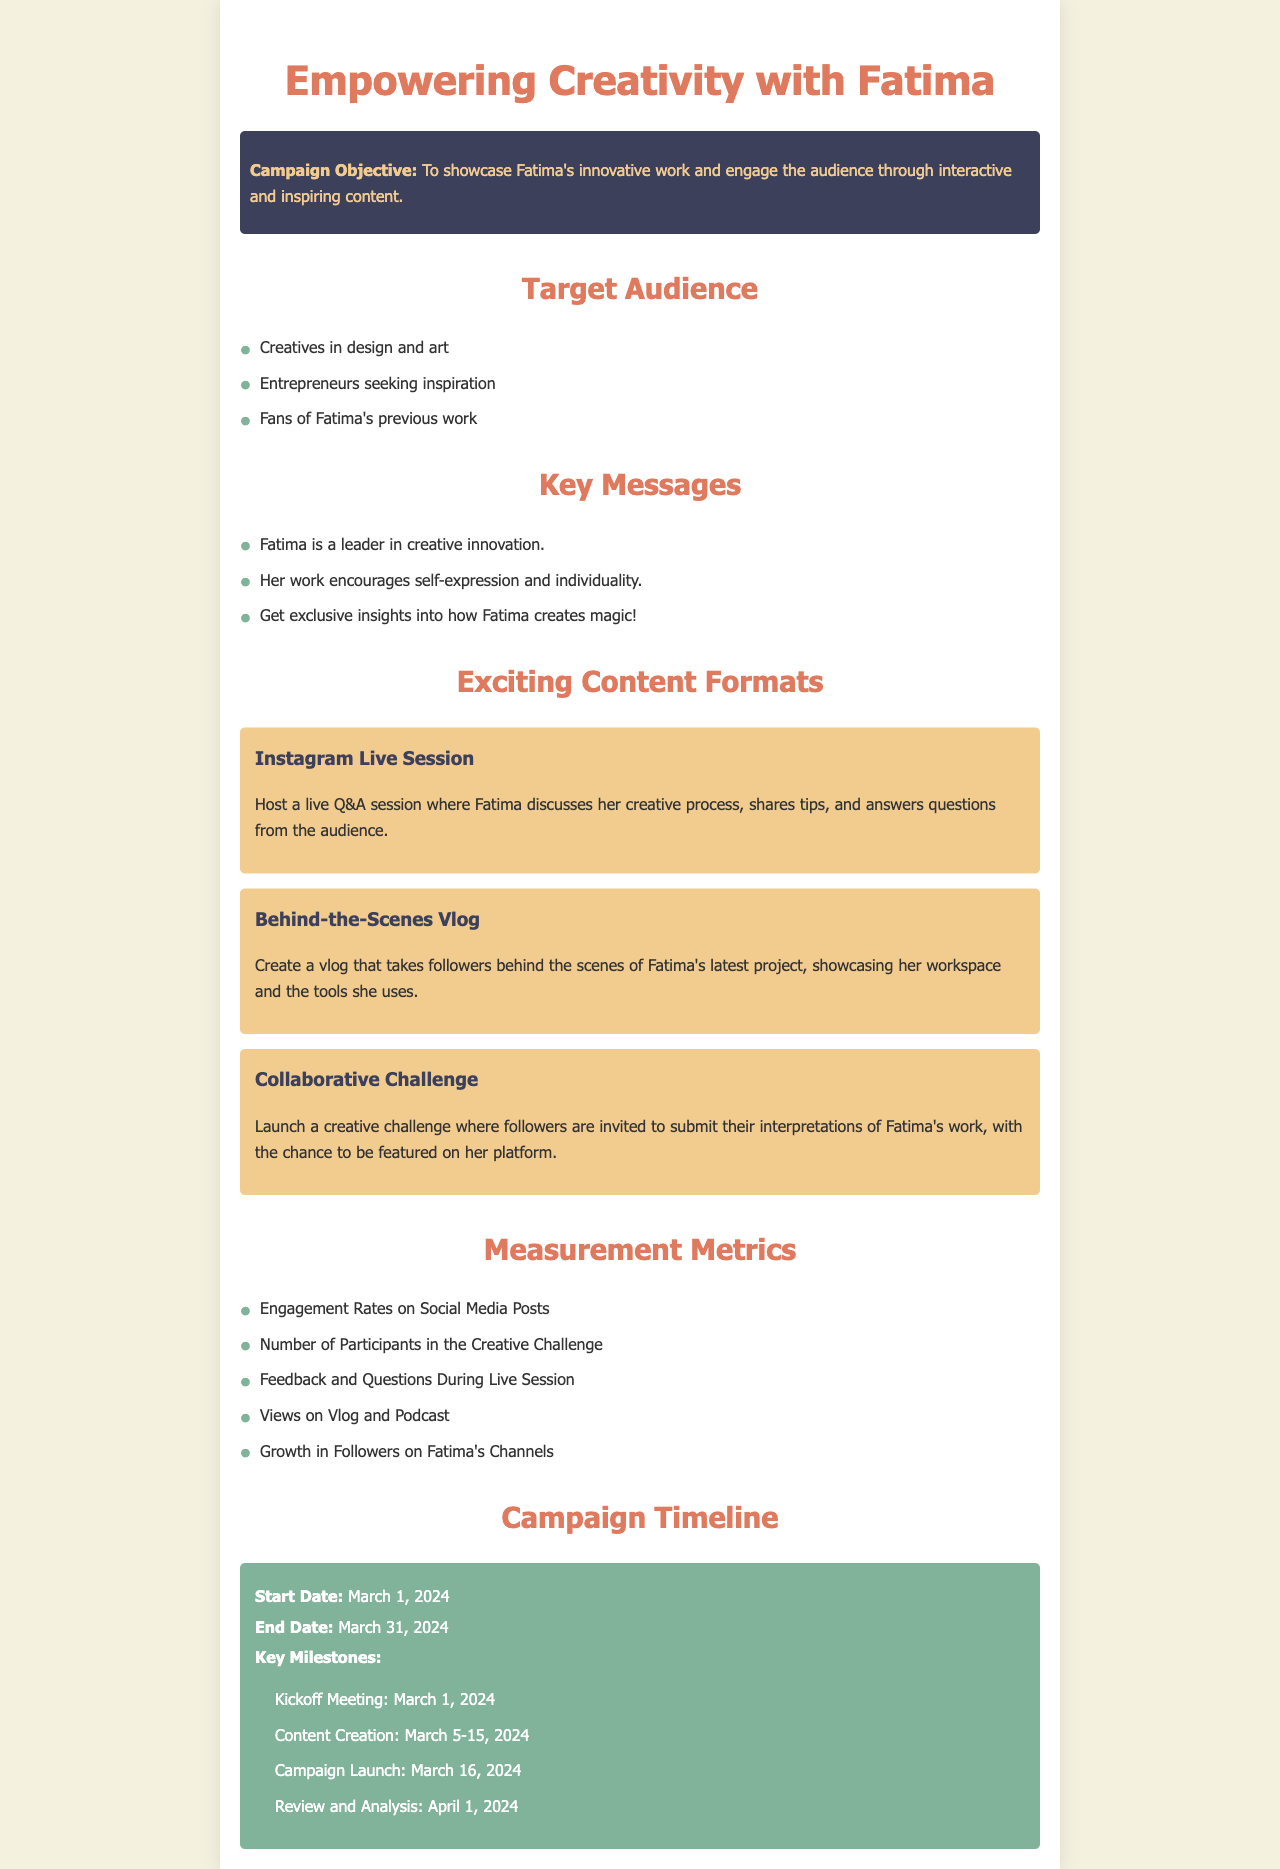What is the campaign objective? The campaign objective is outlined in the document as showcasing Fatima's innovative work and engaging the audience through interactive and inspiring content.
Answer: To showcase Fatima's innovative work and engage the audience through interactive and inspiring content Who is the target audience? The document lists the target audience as people involved in design and art, entrepreneurs seeking inspiration, and fans of Fatima's previous work.
Answer: Creatives in design and art, Entrepreneurs seeking inspiration, Fans of Fatima's previous work What is one of the key messages? The document highlights multiple key messages, one of which states that Fatima is a leader in creative innovation.
Answer: Fatima is a leader in creative innovation What is the start date of the campaign? The start date of the campaign is mentioned in the timeline section of the document.
Answer: March 1, 2024 How many content formats are suggested? The document provides three different content formats for the campaign.
Answer: Three What is one measurement metric mentioned? The document lists various measurement metrics, one of which is engagement rates on social media posts.
Answer: Engagement Rates on Social Media Posts What is the end date of the campaign? The end date of the campaign is clearly stated in the timeline section of the document.
Answer: March 31, 2024 What is the kickoff meeting date? This date is specified in the campaign timeline, indicating when the campaign activities will formally begin.
Answer: March 1, 2024 What activity is scheduled for March 5-15, 2024? This period is dedicated to content creation as specified in the timeline section.
Answer: Content Creation 